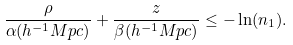<formula> <loc_0><loc_0><loc_500><loc_500>\frac { \rho } { \alpha ( h ^ { - 1 } M p c ) } + \frac { z } { \beta ( h ^ { - 1 } M p c ) } \leq - \ln ( n _ { 1 } ) .</formula> 